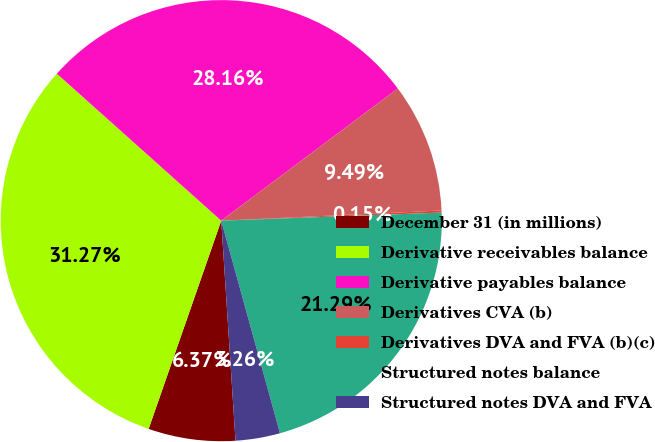Convert chart to OTSL. <chart><loc_0><loc_0><loc_500><loc_500><pie_chart><fcel>December 31 (in millions)<fcel>Derivative receivables balance<fcel>Derivative payables balance<fcel>Derivatives CVA (b)<fcel>Derivatives DVA and FVA (b)(c)<fcel>Structured notes balance<fcel>Structured notes DVA and FVA<nl><fcel>6.37%<fcel>31.27%<fcel>28.16%<fcel>9.49%<fcel>0.15%<fcel>21.29%<fcel>3.26%<nl></chart> 